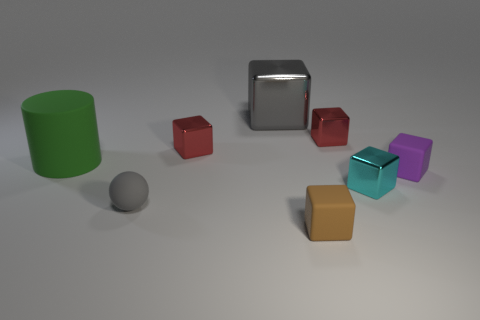Do the matte ball and the large block have the same color?
Your answer should be compact. Yes. What shape is the brown thing that is made of the same material as the big green thing?
Make the answer very short. Cube. How many other things are there of the same shape as the gray metal thing?
Keep it short and to the point. 5. How many red things are shiny things or spheres?
Offer a terse response. 2. Do the tiny cyan thing and the tiny brown object have the same shape?
Your answer should be compact. Yes. Are there any matte spheres that are behind the big thing that is behind the green thing?
Your response must be concise. No. Is the number of blocks that are behind the cyan metallic block the same as the number of brown cubes?
Your answer should be very brief. No. How many other objects are the same size as the rubber cylinder?
Your answer should be very brief. 1. Is the material of the big thing that is to the left of the large metal thing the same as the gray thing that is behind the purple rubber object?
Your answer should be very brief. No. There is a purple rubber thing on the right side of the tiny shiny cube that is in front of the green matte cylinder; what is its size?
Your answer should be very brief. Small. 